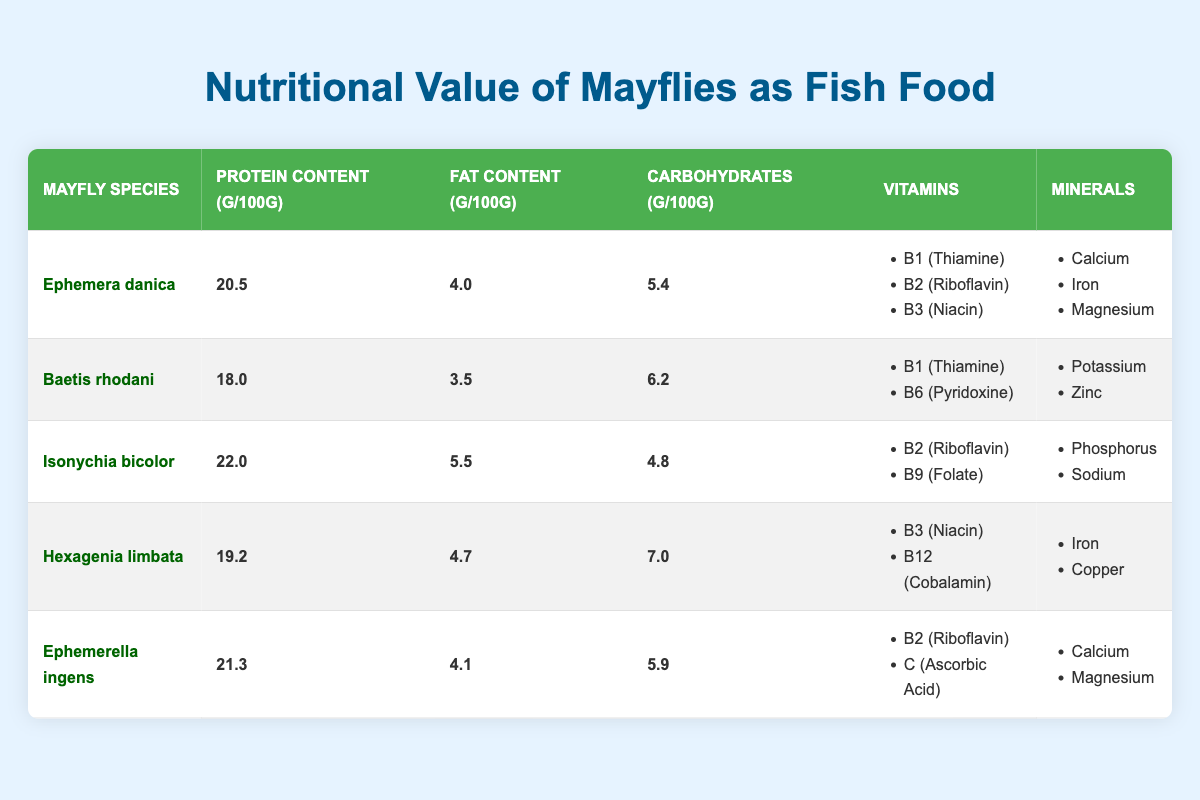What is the protein content of Isonychia bicolor? From the table, Isonychia bicolor has a protein content of 22.0 grams per 100 grams.
Answer: 22.0 g Which mayfly species has the highest fat content? By comparing the fat content values, Isonychia bicolor has the highest fat content at 5.5 grams per 100 grams.
Answer: Isonychia bicolor How many vitamins does Ephemera danica contain? Ephemera danica is listed with three vitamins: B1 (Thiamine), B2 (Riboflavin), and B3 (Niacin).
Answer: 3 What are the total carbohydrate contents of Hexagenia limbata and Baetis rhodani combined? Adding the carbohydrate contents, Hexagenia limbata has 7.0 grams and Baetis rhodani has 6.2 grams. So, 7.0 + 6.2 = 13.2 grams.
Answer: 13.2 g Is there any mayfly species that contains Vitamin B12? In the table, only Hexagenia limbata contains Vitamin B12 (Cobalamin).
Answer: Yes Which mayfly species has the lowest carbohydrate content? The table shows that Isonychia bicolor has the lowest carbohydrate content at 4.8 grams per 100 grams.
Answer: Isonychia bicolor What is the average protein content of all mayfly species listed? To find the average, sum the protein contents: 20.5 + 18.0 + 22.0 + 19.2 + 21.3 = 101.0 grams and divide by the 5 species: 101.0 / 5 = 20.2 grams.
Answer: 20.2 g How many species have Magnesium listed as a mineral? Ephemera danica and Ephemerella ingens both list Magnesium as a mineral, giving a total of 2 species.
Answer: 2 What is the difference in fat content between the mayfly species with the highest and lowest fat content? The highest fat content is 5.5 grams (Isonychia bicolor) and the lowest is 3.5 grams (Baetis rhodani), leading to a difference of 5.5 - 3.5 = 2.0 grams.
Answer: 2.0 g Which mayfly species provide both Calcium and Magnesium as minerals? Ephemera danica and Ephemerella ingens both provide Calcium and Magnesium as minerals, as seen in the table.
Answer: Ephemera danica, Ephemerella ingens 